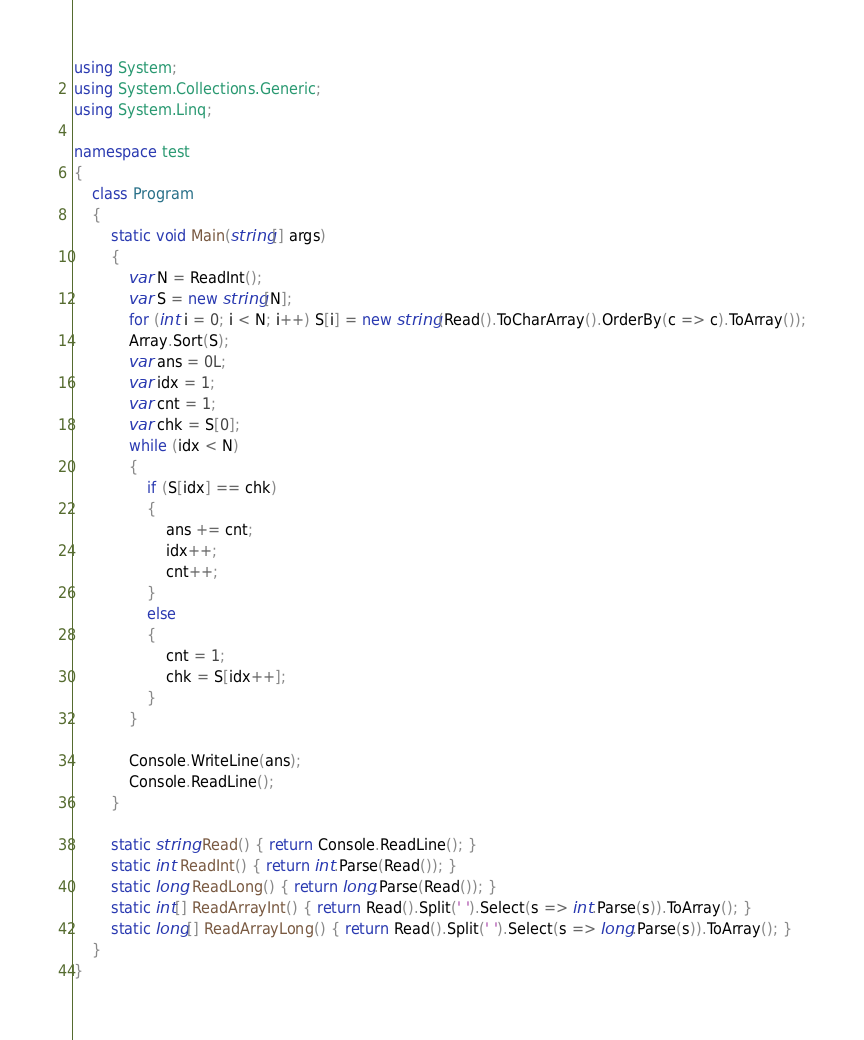Convert code to text. <code><loc_0><loc_0><loc_500><loc_500><_C#_>using System;
using System.Collections.Generic;
using System.Linq;

namespace test
{
    class Program
    {
        static void Main(string[] args)
        {
            var N = ReadInt();
            var S = new string[N];
            for (int i = 0; i < N; i++) S[i] = new string(Read().ToCharArray().OrderBy(c => c).ToArray());
            Array.Sort(S);
            var ans = 0L;
            var idx = 1;
            var cnt = 1;
            var chk = S[0];
            while (idx < N)
            {
                if (S[idx] == chk)
                {
                    ans += cnt;
                    idx++;
                    cnt++;                    
                }
                else
                {
                    cnt = 1;
                    chk = S[idx++];
                }
            }

            Console.WriteLine(ans);
            Console.ReadLine();
        }

        static string Read() { return Console.ReadLine(); }
        static int ReadInt() { return int.Parse(Read()); }
        static long ReadLong() { return long.Parse(Read()); }
        static int[] ReadArrayInt() { return Read().Split(' ').Select(s => int.Parse(s)).ToArray(); }
        static long[] ReadArrayLong() { return Read().Split(' ').Select(s => long.Parse(s)).ToArray(); }
    }
}</code> 